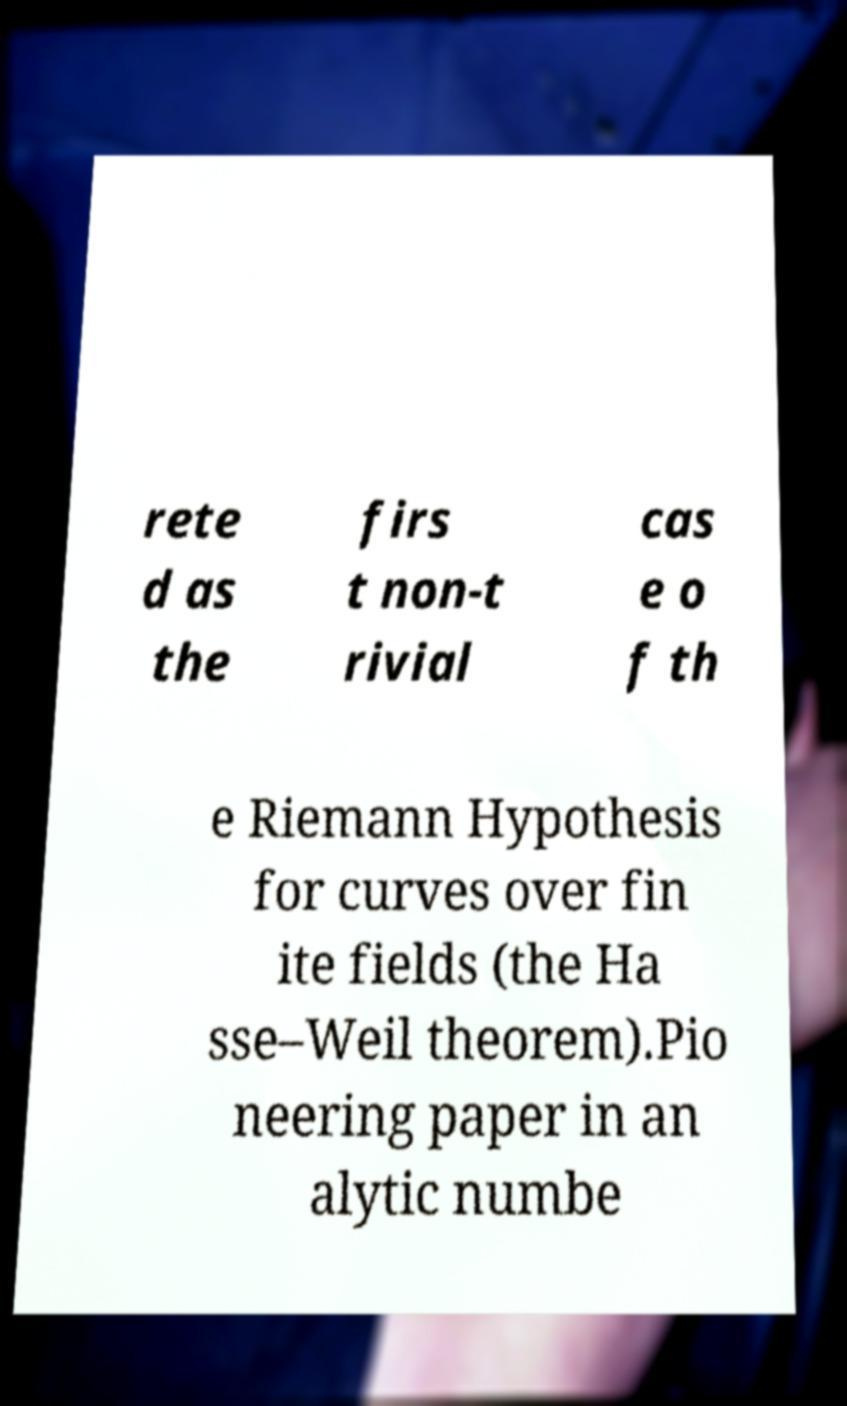Please read and relay the text visible in this image. What does it say? rete d as the firs t non-t rivial cas e o f th e Riemann Hypothesis for curves over fin ite fields (the Ha sse–Weil theorem).Pio neering paper in an alytic numbe 